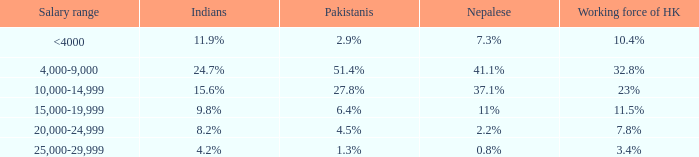8%, what is the proportion for pakistanis? 51.4%. 